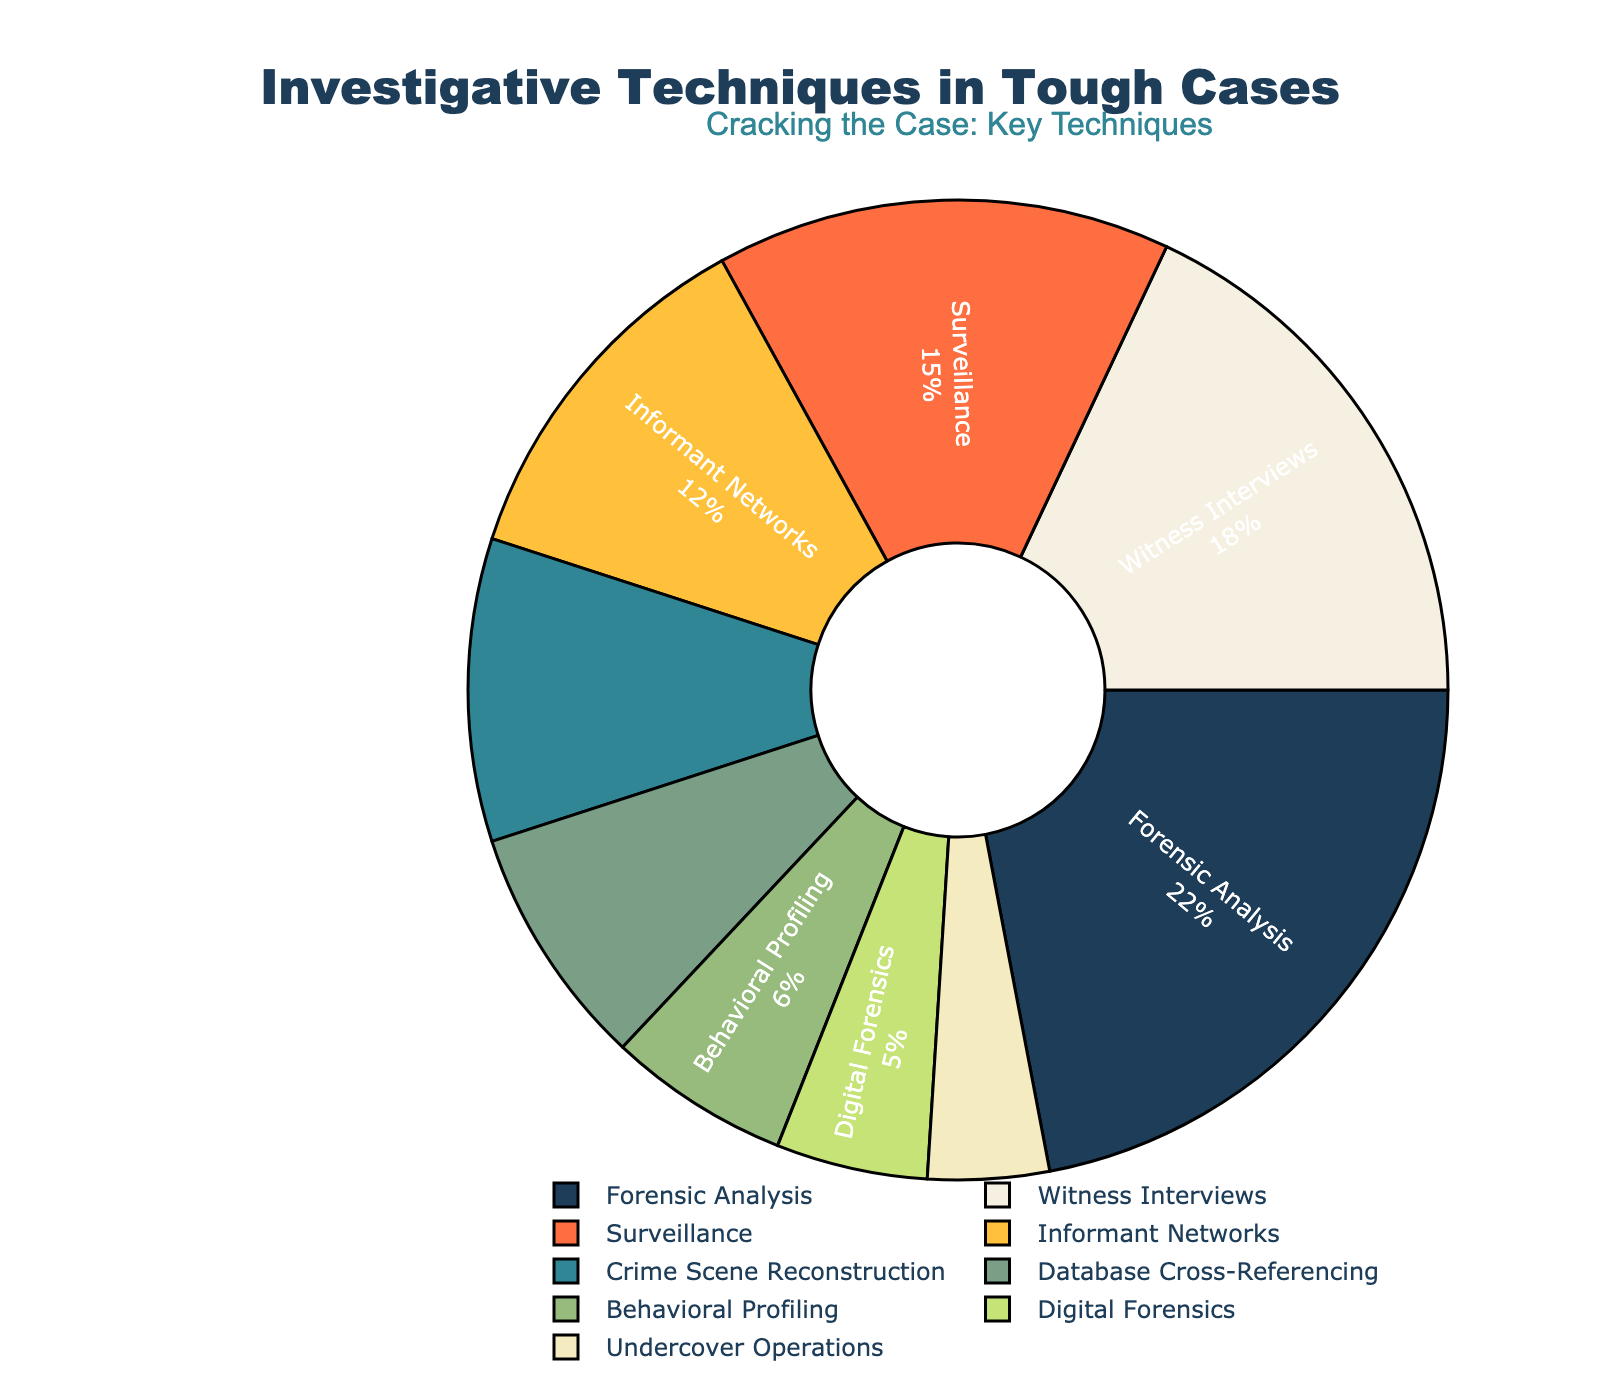What is the most frequently used investigative technique? The technique with the highest percentage represents the most frequently used technique. Referring to the pie chart, Forensic Analysis has the largest slice with 22%.
Answer: Forensic Analysis Which investigative technique is used more, Informant Networks or Digital Forensics? The pie chart shows Informant Networks at 12% and Digital Forensics at 5%. Since 12% is greater than 5%, Informant Networks is used more.
Answer: Informant Networks What is the combined percentage of Surveillance and Witness Interviews? The percentage for Surveillance is 15% and for Witness Interviews is 18%. Adding these together, 15% + 18% = 33%.
Answer: 33% Which investigative technique has the smallest percentage? The smallest segment on the pie chart corresponds to the technique with the lowest percentage. Undercover Operations has the smallest segment with 4%.
Answer: Undercover Operations How much more frequently is Forensic Analysis used compared to Behavioral Profiling? Forensic Analysis has a percentage of 22% and Behavioral Profiling has 6%. The difference is 22% - 6% = 16%.
Answer: 16% Are Witness Interviews used more frequently than Crime Scene Reconstruction? The chart shows Witness Interviews at 18% and Crime Scene Reconstruction at 10%. 18% is greater than 10%, so Witness Interviews are used more frequently.
Answer: Yes Combine the percentages of the least three frequently used techniques. What is the total? The three least frequently used techniques are Undercover Operations (4%), Digital Forensics (5%), and Behavioral Profiling (6%). Their combined percentage is 4% + 5% + 6% = 15%.
Answer: 15% Which techniques together contribute exactly half (50%) of the investigation methods used? Adding the percentages from the chart, Forensic Analysis (22%), Witness Interviews (18%), and Surveillance (15%) come closest but exceed 50%. Instead, Forensic Analysis (22%), Witness Interviews (18%), and Informant Networks (12%) together total 52%, just beyond. Forensic Analysis (22%), Witness Interviews (18%), and Database Cross-Referencing (8%) total 48%, which is not exactly 50%. Thus, no exact combination of techniques sums to 50%.
Answer: None Is Crime Scene Reconstruction used more frequently than Database Cross-Referencing? The chart shows Crime Scene Reconstruction at 10% and Database Cross-Referencing at 8%. Since 10% is greater than 8%, Crime Scene Reconstruction is used more frequently.
Answer: Yes What proportion of the investigative techniques are forensic-related if you combine Forensic Analysis and Digital Forensics? Forensic Analysis is 22% and Digital Forensics is 5%. Combining these, 22% + 5% = 27%.
Answer: 27% 